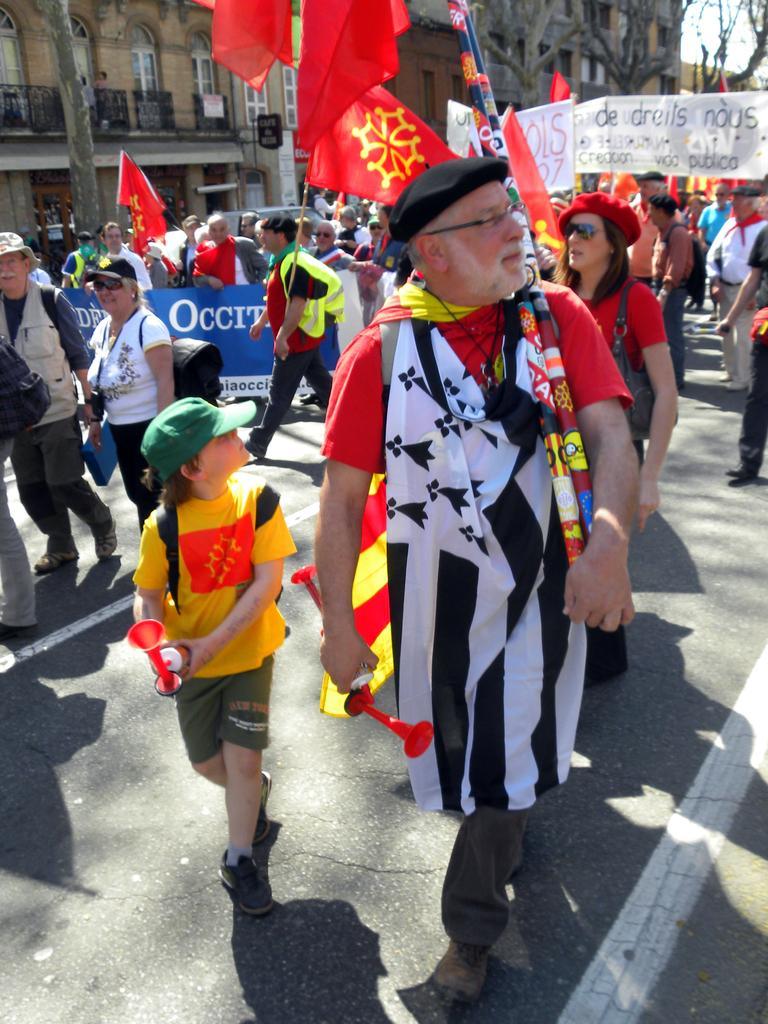Can you describe this image briefly? In the foreground of this image, there are people wearing bags and holding flags are walking on the road. Few are holding banners. In the background, there are buildings, trees and the sky. 